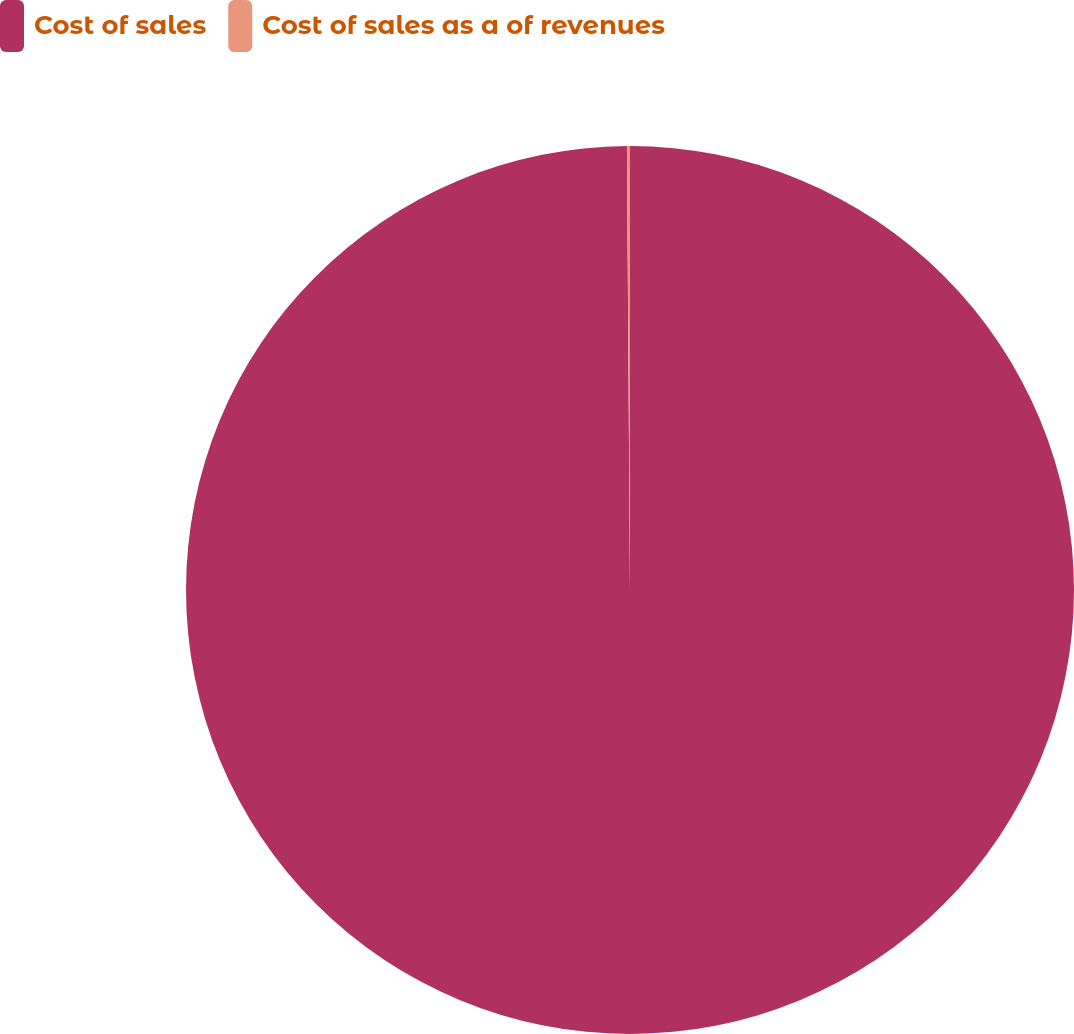Convert chart to OTSL. <chart><loc_0><loc_0><loc_500><loc_500><pie_chart><fcel>Cost of sales<fcel>Cost of sales as a of revenues<nl><fcel>99.89%<fcel>0.11%<nl></chart> 